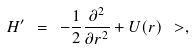Convert formula to latex. <formula><loc_0><loc_0><loc_500><loc_500>H ^ { \prime } \ = \ - \frac { 1 } { 2 } \frac { \partial ^ { 2 } } { \partial r ^ { 2 } } + U ( r ) \ > ,</formula> 